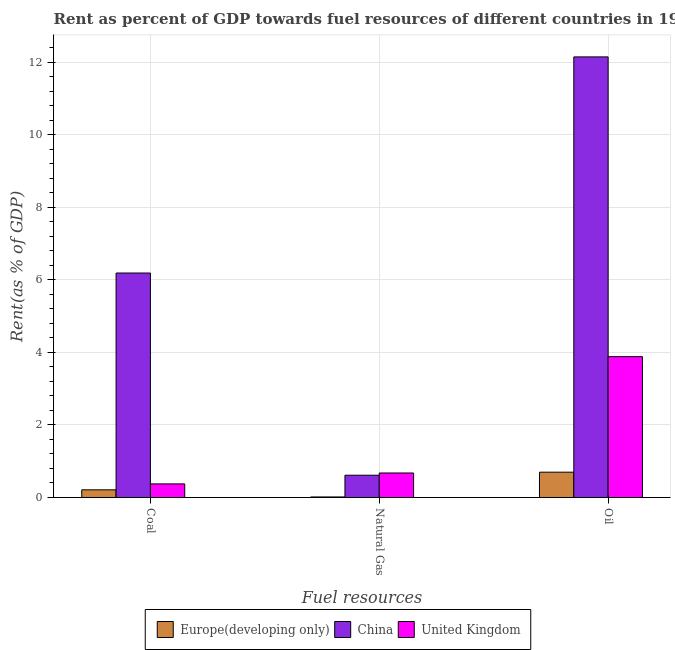How many different coloured bars are there?
Offer a terse response. 3. Are the number of bars on each tick of the X-axis equal?
Provide a succinct answer. Yes. What is the label of the 3rd group of bars from the left?
Your answer should be compact. Oil. What is the rent towards oil in United Kingdom?
Provide a short and direct response. 3.88. Across all countries, what is the maximum rent towards natural gas?
Offer a terse response. 0.68. Across all countries, what is the minimum rent towards coal?
Keep it short and to the point. 0.21. In which country was the rent towards coal minimum?
Your answer should be compact. Europe(developing only). What is the total rent towards natural gas in the graph?
Offer a very short reply. 1.3. What is the difference between the rent towards coal in United Kingdom and that in China?
Keep it short and to the point. -5.81. What is the difference between the rent towards natural gas in United Kingdom and the rent towards coal in Europe(developing only)?
Offer a very short reply. 0.46. What is the average rent towards oil per country?
Make the answer very short. 5.58. What is the difference between the rent towards coal and rent towards natural gas in United Kingdom?
Offer a terse response. -0.3. In how many countries, is the rent towards coal greater than 3.6 %?
Offer a terse response. 1. What is the ratio of the rent towards natural gas in United Kingdom to that in China?
Ensure brevity in your answer.  1.1. What is the difference between the highest and the second highest rent towards coal?
Give a very brief answer. 5.81. What is the difference between the highest and the lowest rent towards oil?
Your response must be concise. 11.45. In how many countries, is the rent towards natural gas greater than the average rent towards natural gas taken over all countries?
Make the answer very short. 2. Is the sum of the rent towards natural gas in China and United Kingdom greater than the maximum rent towards oil across all countries?
Offer a terse response. No. What does the 1st bar from the left in Natural Gas represents?
Offer a very short reply. Europe(developing only). What does the 3rd bar from the right in Coal represents?
Provide a succinct answer. Europe(developing only). Is it the case that in every country, the sum of the rent towards coal and rent towards natural gas is greater than the rent towards oil?
Make the answer very short. No. Does the graph contain any zero values?
Offer a very short reply. No. Where does the legend appear in the graph?
Provide a short and direct response. Bottom center. What is the title of the graph?
Ensure brevity in your answer.  Rent as percent of GDP towards fuel resources of different countries in 1981. Does "Kuwait" appear as one of the legend labels in the graph?
Your answer should be very brief. No. What is the label or title of the X-axis?
Offer a very short reply. Fuel resources. What is the label or title of the Y-axis?
Your answer should be compact. Rent(as % of GDP). What is the Rent(as % of GDP) in Europe(developing only) in Coal?
Ensure brevity in your answer.  0.21. What is the Rent(as % of GDP) in China in Coal?
Your answer should be very brief. 6.19. What is the Rent(as % of GDP) of United Kingdom in Coal?
Your response must be concise. 0.37. What is the Rent(as % of GDP) in Europe(developing only) in Natural Gas?
Make the answer very short. 0.02. What is the Rent(as % of GDP) in China in Natural Gas?
Make the answer very short. 0.61. What is the Rent(as % of GDP) of United Kingdom in Natural Gas?
Keep it short and to the point. 0.68. What is the Rent(as % of GDP) of Europe(developing only) in Oil?
Your answer should be compact. 0.7. What is the Rent(as % of GDP) in China in Oil?
Offer a very short reply. 12.15. What is the Rent(as % of GDP) of United Kingdom in Oil?
Keep it short and to the point. 3.88. Across all Fuel resources, what is the maximum Rent(as % of GDP) of Europe(developing only)?
Provide a succinct answer. 0.7. Across all Fuel resources, what is the maximum Rent(as % of GDP) in China?
Provide a short and direct response. 12.15. Across all Fuel resources, what is the maximum Rent(as % of GDP) of United Kingdom?
Your answer should be very brief. 3.88. Across all Fuel resources, what is the minimum Rent(as % of GDP) of Europe(developing only)?
Provide a short and direct response. 0.02. Across all Fuel resources, what is the minimum Rent(as % of GDP) of China?
Provide a short and direct response. 0.61. Across all Fuel resources, what is the minimum Rent(as % of GDP) of United Kingdom?
Provide a succinct answer. 0.37. What is the total Rent(as % of GDP) of Europe(developing only) in the graph?
Your answer should be compact. 0.92. What is the total Rent(as % of GDP) in China in the graph?
Your answer should be very brief. 18.95. What is the total Rent(as % of GDP) in United Kingdom in the graph?
Make the answer very short. 4.93. What is the difference between the Rent(as % of GDP) in Europe(developing only) in Coal and that in Natural Gas?
Give a very brief answer. 0.2. What is the difference between the Rent(as % of GDP) of China in Coal and that in Natural Gas?
Make the answer very short. 5.57. What is the difference between the Rent(as % of GDP) of United Kingdom in Coal and that in Natural Gas?
Provide a succinct answer. -0.3. What is the difference between the Rent(as % of GDP) of Europe(developing only) in Coal and that in Oil?
Offer a very short reply. -0.49. What is the difference between the Rent(as % of GDP) of China in Coal and that in Oil?
Your answer should be compact. -5.96. What is the difference between the Rent(as % of GDP) of United Kingdom in Coal and that in Oil?
Offer a terse response. -3.51. What is the difference between the Rent(as % of GDP) in Europe(developing only) in Natural Gas and that in Oil?
Make the answer very short. -0.68. What is the difference between the Rent(as % of GDP) of China in Natural Gas and that in Oil?
Your answer should be very brief. -11.53. What is the difference between the Rent(as % of GDP) of United Kingdom in Natural Gas and that in Oil?
Keep it short and to the point. -3.21. What is the difference between the Rent(as % of GDP) of Europe(developing only) in Coal and the Rent(as % of GDP) of China in Natural Gas?
Give a very brief answer. -0.4. What is the difference between the Rent(as % of GDP) in Europe(developing only) in Coal and the Rent(as % of GDP) in United Kingdom in Natural Gas?
Make the answer very short. -0.46. What is the difference between the Rent(as % of GDP) of China in Coal and the Rent(as % of GDP) of United Kingdom in Natural Gas?
Provide a short and direct response. 5.51. What is the difference between the Rent(as % of GDP) of Europe(developing only) in Coal and the Rent(as % of GDP) of China in Oil?
Provide a succinct answer. -11.93. What is the difference between the Rent(as % of GDP) of Europe(developing only) in Coal and the Rent(as % of GDP) of United Kingdom in Oil?
Your answer should be very brief. -3.67. What is the difference between the Rent(as % of GDP) in China in Coal and the Rent(as % of GDP) in United Kingdom in Oil?
Your response must be concise. 2.31. What is the difference between the Rent(as % of GDP) in Europe(developing only) in Natural Gas and the Rent(as % of GDP) in China in Oil?
Provide a succinct answer. -12.13. What is the difference between the Rent(as % of GDP) in Europe(developing only) in Natural Gas and the Rent(as % of GDP) in United Kingdom in Oil?
Offer a terse response. -3.87. What is the difference between the Rent(as % of GDP) in China in Natural Gas and the Rent(as % of GDP) in United Kingdom in Oil?
Your answer should be very brief. -3.27. What is the average Rent(as % of GDP) of Europe(developing only) per Fuel resources?
Give a very brief answer. 0.31. What is the average Rent(as % of GDP) of China per Fuel resources?
Your answer should be very brief. 6.32. What is the average Rent(as % of GDP) of United Kingdom per Fuel resources?
Make the answer very short. 1.64. What is the difference between the Rent(as % of GDP) of Europe(developing only) and Rent(as % of GDP) of China in Coal?
Your answer should be compact. -5.98. What is the difference between the Rent(as % of GDP) of Europe(developing only) and Rent(as % of GDP) of United Kingdom in Coal?
Your response must be concise. -0.16. What is the difference between the Rent(as % of GDP) of China and Rent(as % of GDP) of United Kingdom in Coal?
Make the answer very short. 5.81. What is the difference between the Rent(as % of GDP) of Europe(developing only) and Rent(as % of GDP) of China in Natural Gas?
Your answer should be compact. -0.6. What is the difference between the Rent(as % of GDP) of Europe(developing only) and Rent(as % of GDP) of United Kingdom in Natural Gas?
Keep it short and to the point. -0.66. What is the difference between the Rent(as % of GDP) of China and Rent(as % of GDP) of United Kingdom in Natural Gas?
Provide a short and direct response. -0.06. What is the difference between the Rent(as % of GDP) of Europe(developing only) and Rent(as % of GDP) of China in Oil?
Your answer should be compact. -11.45. What is the difference between the Rent(as % of GDP) of Europe(developing only) and Rent(as % of GDP) of United Kingdom in Oil?
Provide a short and direct response. -3.19. What is the difference between the Rent(as % of GDP) in China and Rent(as % of GDP) in United Kingdom in Oil?
Your answer should be very brief. 8.26. What is the ratio of the Rent(as % of GDP) of Europe(developing only) in Coal to that in Natural Gas?
Make the answer very short. 13.96. What is the ratio of the Rent(as % of GDP) of China in Coal to that in Natural Gas?
Provide a succinct answer. 10.08. What is the ratio of the Rent(as % of GDP) of United Kingdom in Coal to that in Natural Gas?
Your answer should be very brief. 0.55. What is the ratio of the Rent(as % of GDP) in Europe(developing only) in Coal to that in Oil?
Give a very brief answer. 0.3. What is the ratio of the Rent(as % of GDP) in China in Coal to that in Oil?
Your answer should be compact. 0.51. What is the ratio of the Rent(as % of GDP) of United Kingdom in Coal to that in Oil?
Your answer should be very brief. 0.1. What is the ratio of the Rent(as % of GDP) of Europe(developing only) in Natural Gas to that in Oil?
Your answer should be compact. 0.02. What is the ratio of the Rent(as % of GDP) of China in Natural Gas to that in Oil?
Offer a terse response. 0.05. What is the ratio of the Rent(as % of GDP) of United Kingdom in Natural Gas to that in Oil?
Give a very brief answer. 0.17. What is the difference between the highest and the second highest Rent(as % of GDP) of Europe(developing only)?
Give a very brief answer. 0.49. What is the difference between the highest and the second highest Rent(as % of GDP) of China?
Your response must be concise. 5.96. What is the difference between the highest and the second highest Rent(as % of GDP) in United Kingdom?
Your answer should be compact. 3.21. What is the difference between the highest and the lowest Rent(as % of GDP) of Europe(developing only)?
Give a very brief answer. 0.68. What is the difference between the highest and the lowest Rent(as % of GDP) in China?
Provide a short and direct response. 11.53. What is the difference between the highest and the lowest Rent(as % of GDP) in United Kingdom?
Provide a succinct answer. 3.51. 